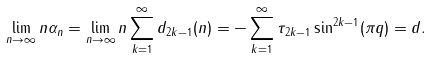Convert formula to latex. <formula><loc_0><loc_0><loc_500><loc_500>\lim _ { n \to \infty } n \alpha _ { n } = \lim _ { n \to \infty } n \sum _ { k = 1 } ^ { \infty } d _ { 2 k - 1 } ( n ) = - \sum _ { k = 1 } ^ { \infty } \tau _ { 2 k - 1 } \sin ^ { 2 k - 1 } ( \pi q ) = d .</formula> 